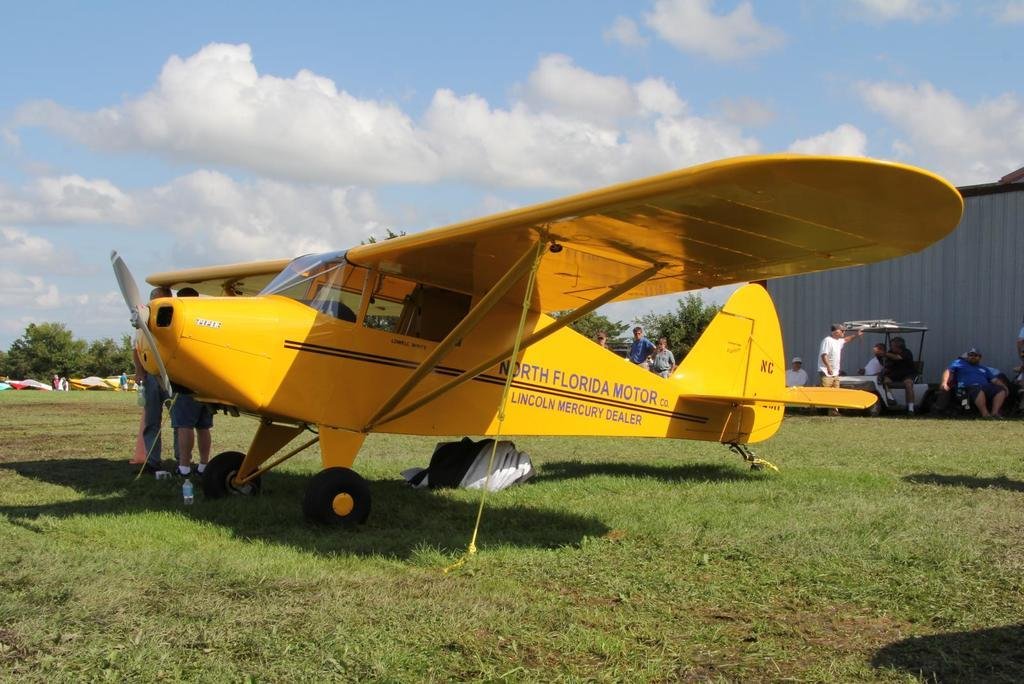<image>
Render a clear and concise summary of the photo. A yellow airplane from North Florida motor co is parked int he grass. 